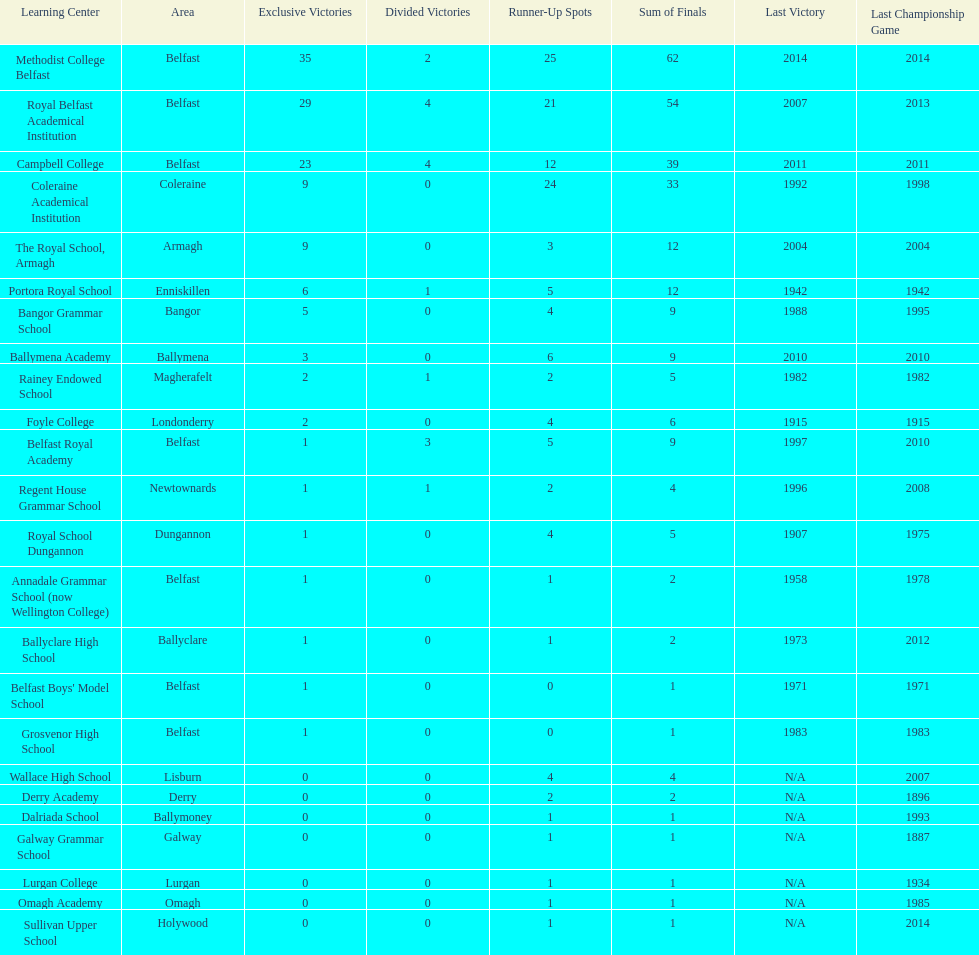How many schools have at least 5 outright titles? 7. Could you parse the entire table? {'header': ['Learning Center', 'Area', 'Exclusive Victories', 'Divided Victories', 'Runner-Up Spots', 'Sum of Finals', 'Last Victory', 'Last Championship Game'], 'rows': [['Methodist College Belfast', 'Belfast', '35', '2', '25', '62', '2014', '2014'], ['Royal Belfast Academical Institution', 'Belfast', '29', '4', '21', '54', '2007', '2013'], ['Campbell College', 'Belfast', '23', '4', '12', '39', '2011', '2011'], ['Coleraine Academical Institution', 'Coleraine', '9', '0', '24', '33', '1992', '1998'], ['The Royal School, Armagh', 'Armagh', '9', '0', '3', '12', '2004', '2004'], ['Portora Royal School', 'Enniskillen', '6', '1', '5', '12', '1942', '1942'], ['Bangor Grammar School', 'Bangor', '5', '0', '4', '9', '1988', '1995'], ['Ballymena Academy', 'Ballymena', '3', '0', '6', '9', '2010', '2010'], ['Rainey Endowed School', 'Magherafelt', '2', '1', '2', '5', '1982', '1982'], ['Foyle College', 'Londonderry', '2', '0', '4', '6', '1915', '1915'], ['Belfast Royal Academy', 'Belfast', '1', '3', '5', '9', '1997', '2010'], ['Regent House Grammar School', 'Newtownards', '1', '1', '2', '4', '1996', '2008'], ['Royal School Dungannon', 'Dungannon', '1', '0', '4', '5', '1907', '1975'], ['Annadale Grammar School (now Wellington College)', 'Belfast', '1', '0', '1', '2', '1958', '1978'], ['Ballyclare High School', 'Ballyclare', '1', '0', '1', '2', '1973', '2012'], ["Belfast Boys' Model School", 'Belfast', '1', '0', '0', '1', '1971', '1971'], ['Grosvenor High School', 'Belfast', '1', '0', '0', '1', '1983', '1983'], ['Wallace High School', 'Lisburn', '0', '0', '4', '4', 'N/A', '2007'], ['Derry Academy', 'Derry', '0', '0', '2', '2', 'N/A', '1896'], ['Dalriada School', 'Ballymoney', '0', '0', '1', '1', 'N/A', '1993'], ['Galway Grammar School', 'Galway', '0', '0', '1', '1', 'N/A', '1887'], ['Lurgan College', 'Lurgan', '0', '0', '1', '1', 'N/A', '1934'], ['Omagh Academy', 'Omagh', '0', '0', '1', '1', 'N/A', '1985'], ['Sullivan Upper School', 'Holywood', '0', '0', '1', '1', 'N/A', '2014']]} 